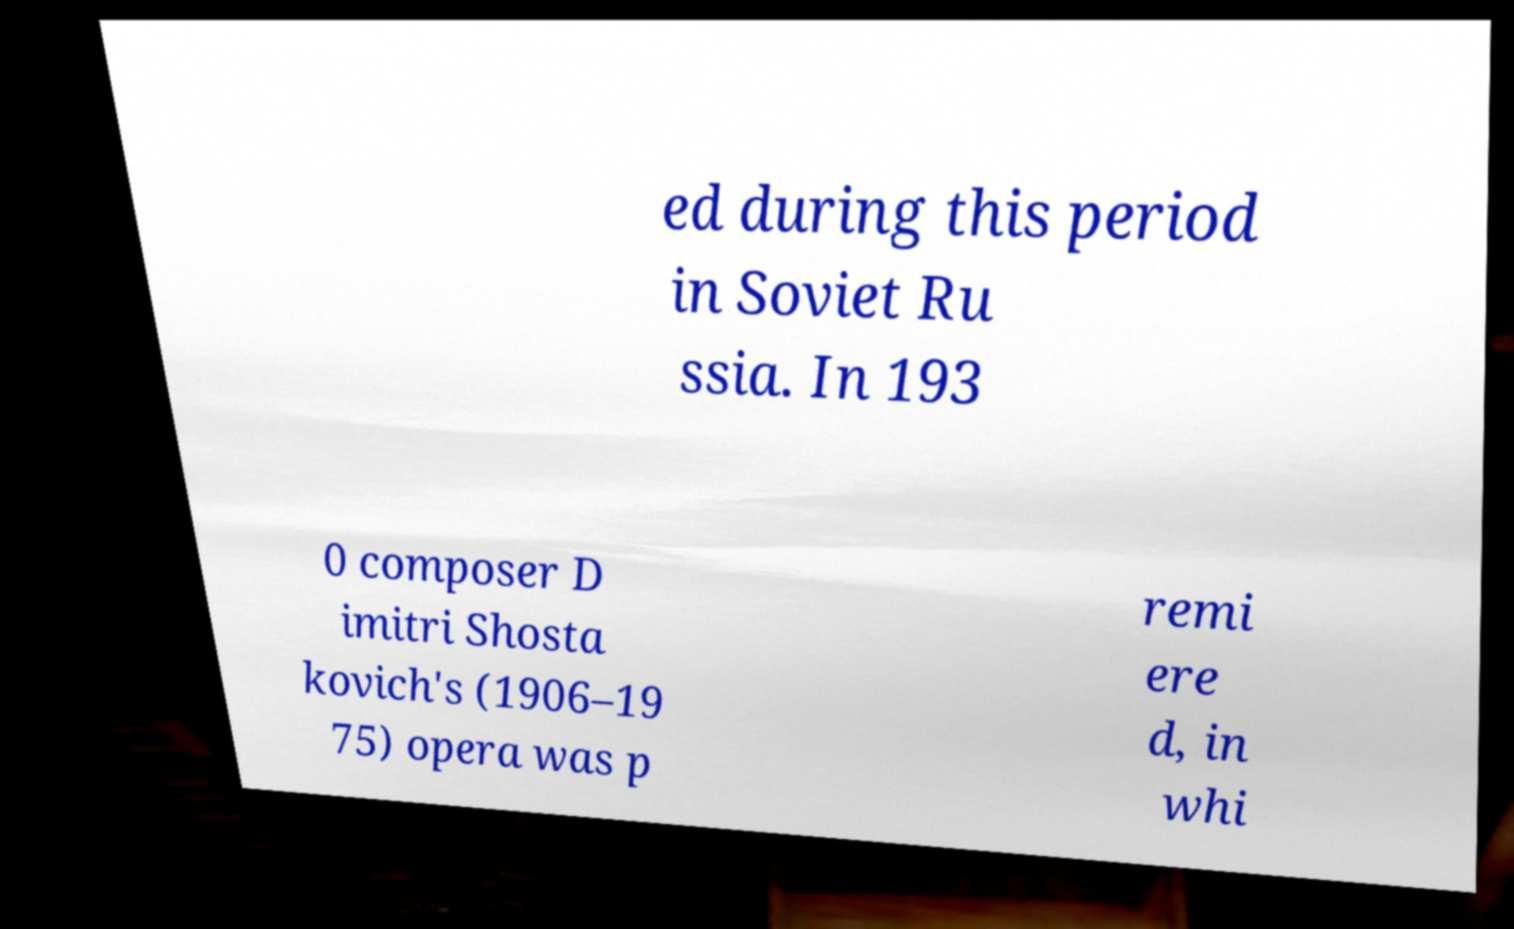For documentation purposes, I need the text within this image transcribed. Could you provide that? ed during this period in Soviet Ru ssia. In 193 0 composer D imitri Shosta kovich's (1906–19 75) opera was p remi ere d, in whi 